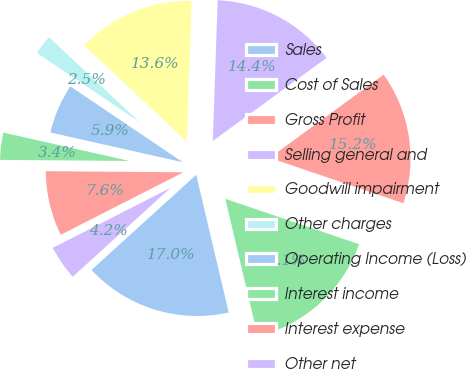Convert chart to OTSL. <chart><loc_0><loc_0><loc_500><loc_500><pie_chart><fcel>Sales<fcel>Cost of Sales<fcel>Gross Profit<fcel>Selling general and<fcel>Goodwill impairment<fcel>Other charges<fcel>Operating Income (Loss)<fcel>Interest income<fcel>Interest expense<fcel>Other net<nl><fcel>16.95%<fcel>16.1%<fcel>15.25%<fcel>14.41%<fcel>13.56%<fcel>2.54%<fcel>5.93%<fcel>3.39%<fcel>7.63%<fcel>4.24%<nl></chart> 